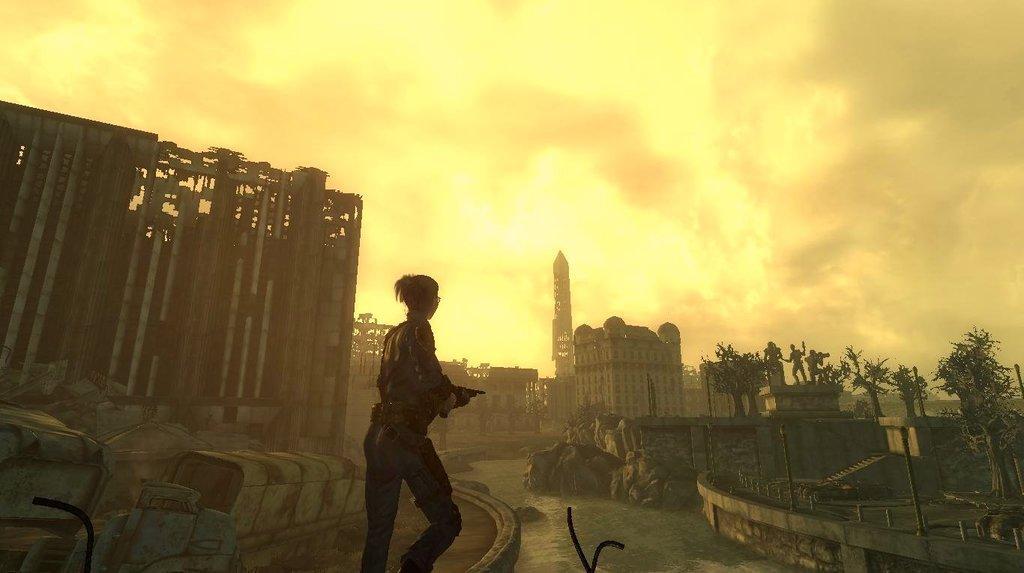Can you describe this image briefly? This is a animated image. In the center of the image there is a lady holding a gun. In the background of the image there are buildings, trees, statues. In the center of the image there is water. At the top of the image there is sky and clouds. 